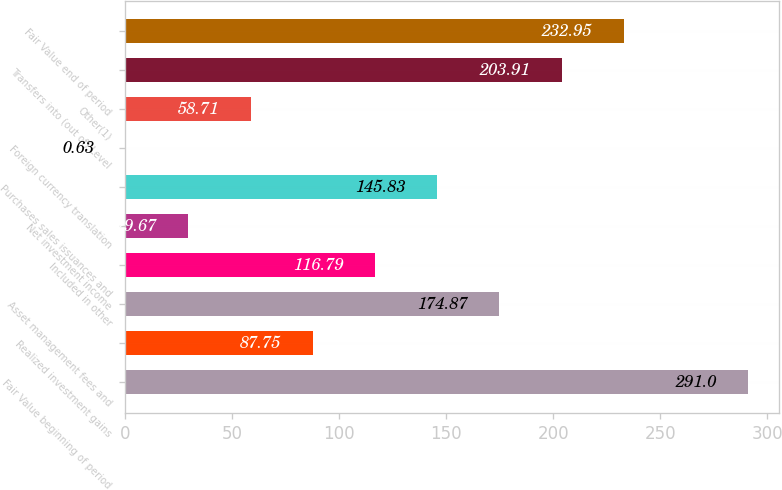Convert chart to OTSL. <chart><loc_0><loc_0><loc_500><loc_500><bar_chart><fcel>Fair Value beginning of period<fcel>Realized investment gains<fcel>Asset management fees and<fcel>Included in other<fcel>Net investment income<fcel>Purchases sales issuances and<fcel>Foreign currency translation<fcel>Other(1)<fcel>Transfers into (out of) Level<fcel>Fair Value end of period<nl><fcel>291<fcel>87.75<fcel>174.87<fcel>116.79<fcel>29.67<fcel>145.83<fcel>0.63<fcel>58.71<fcel>203.91<fcel>232.95<nl></chart> 